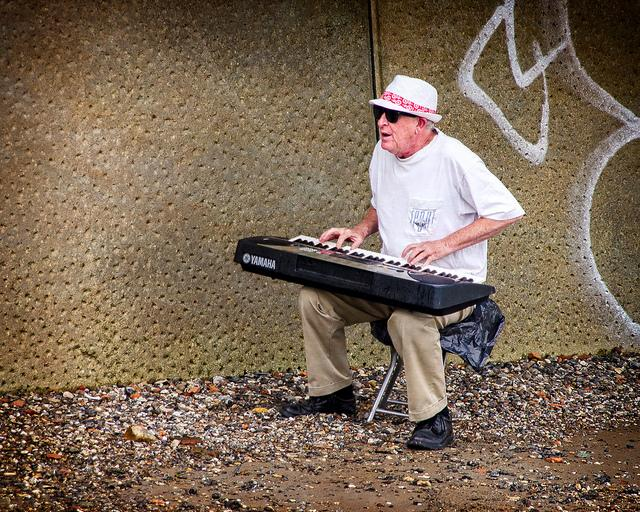What powers the musical instrument shown here?

Choices:
A) solar
B) gas
C) battery
D) oil battery 